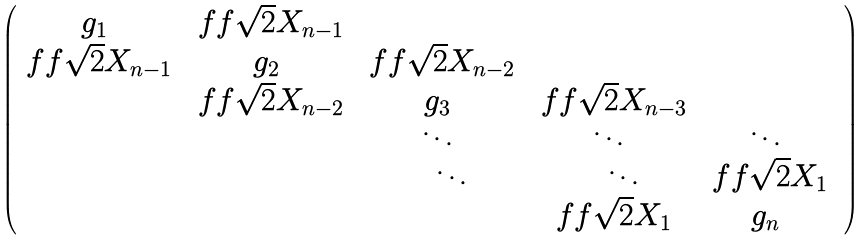Convert formula to latex. <formula><loc_0><loc_0><loc_500><loc_500>\begin{pmatrix} g _ { 1 } & \ f f { \sqrt { 2 } } X _ { n - 1 } & & & \\ \ f f { \sqrt { 2 } } X _ { n - 1 } & g _ { 2 } & \ f f { \sqrt { 2 } } X _ { n - 2 } & & \\ & \ f f { \sqrt { 2 } } X _ { n - 2 } & g _ { 3 } & \ f f { \sqrt { 2 } } X _ { n - 3 } & \\ & & \ddots & \ddots & \ddots & \\ & & \quad \ddots & \quad \ddots & \ f f { \sqrt { 2 } } X _ { 1 } & \\ & & & \ f f { \sqrt { 2 } } X _ { 1 } & g _ { n } \end{pmatrix}</formula> 